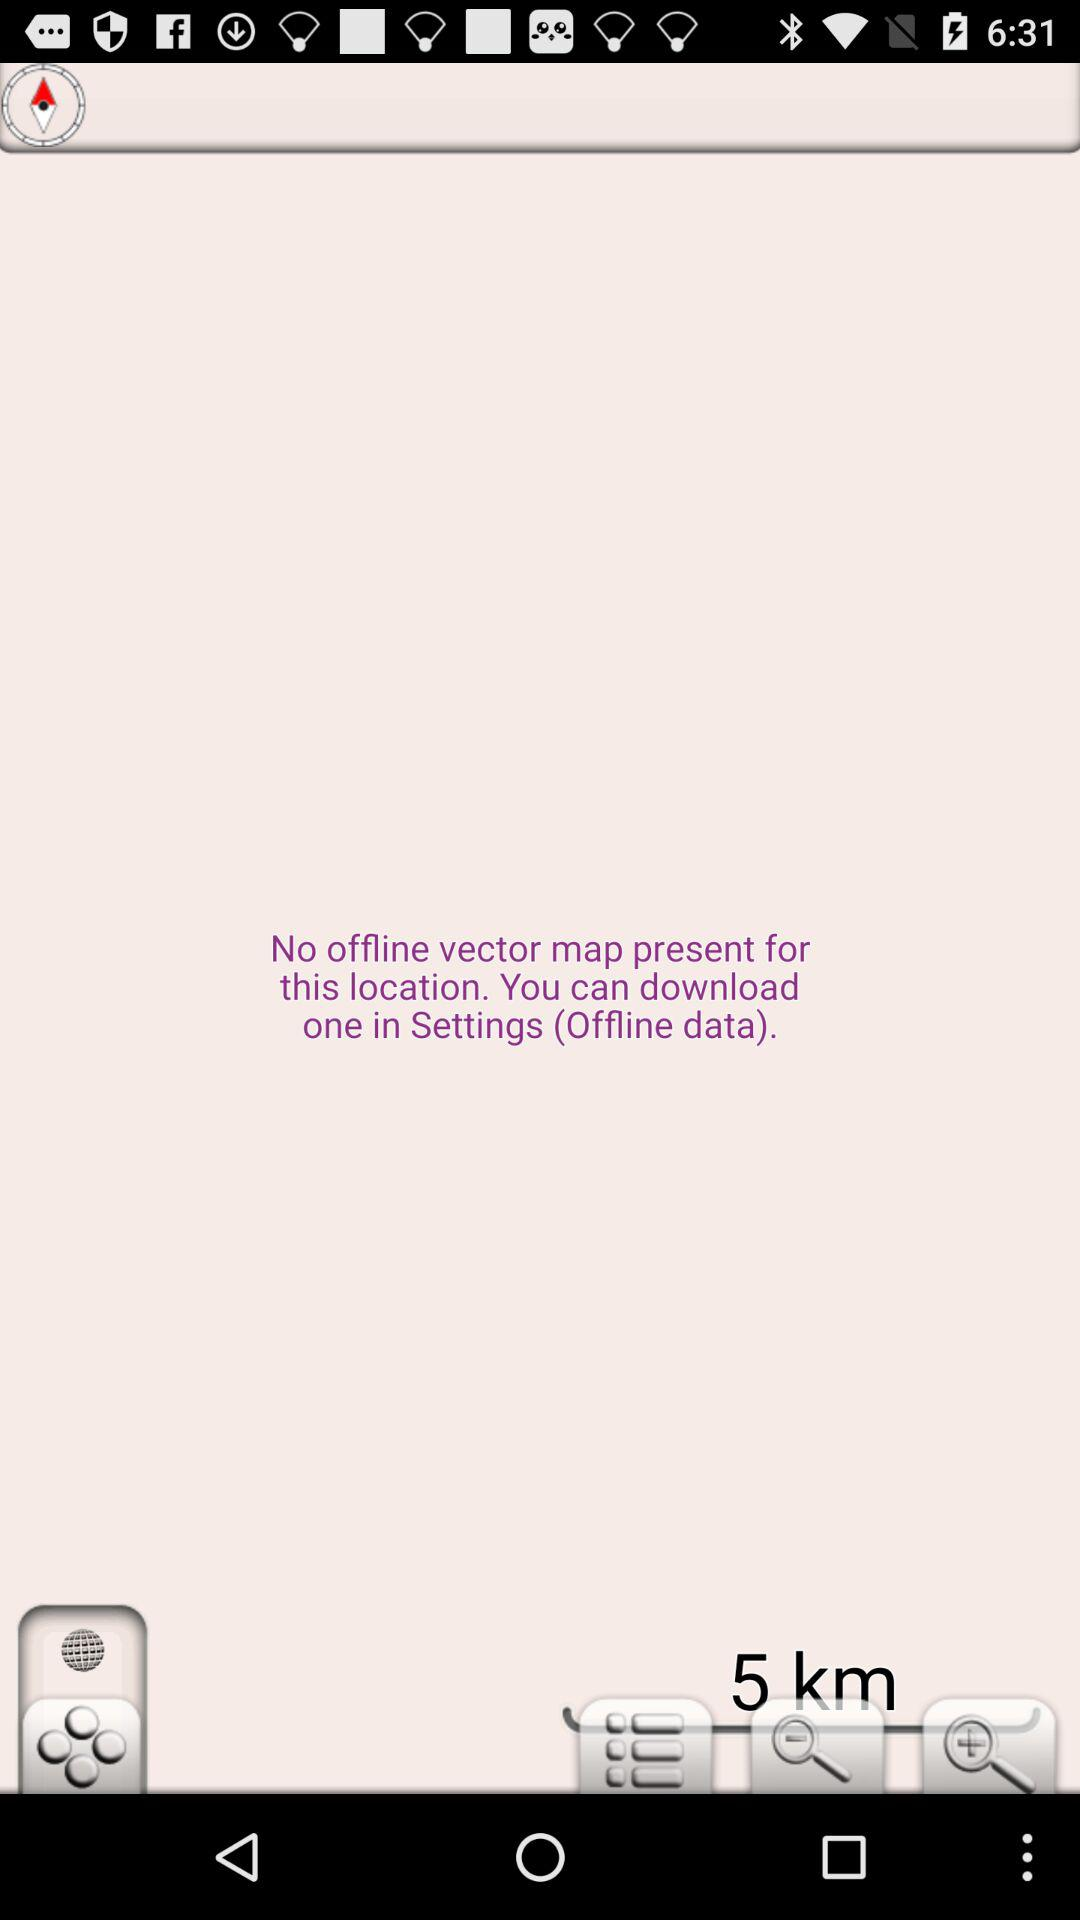How many kilometers away is the nearest place?
Answer the question using a single word or phrase. 5 